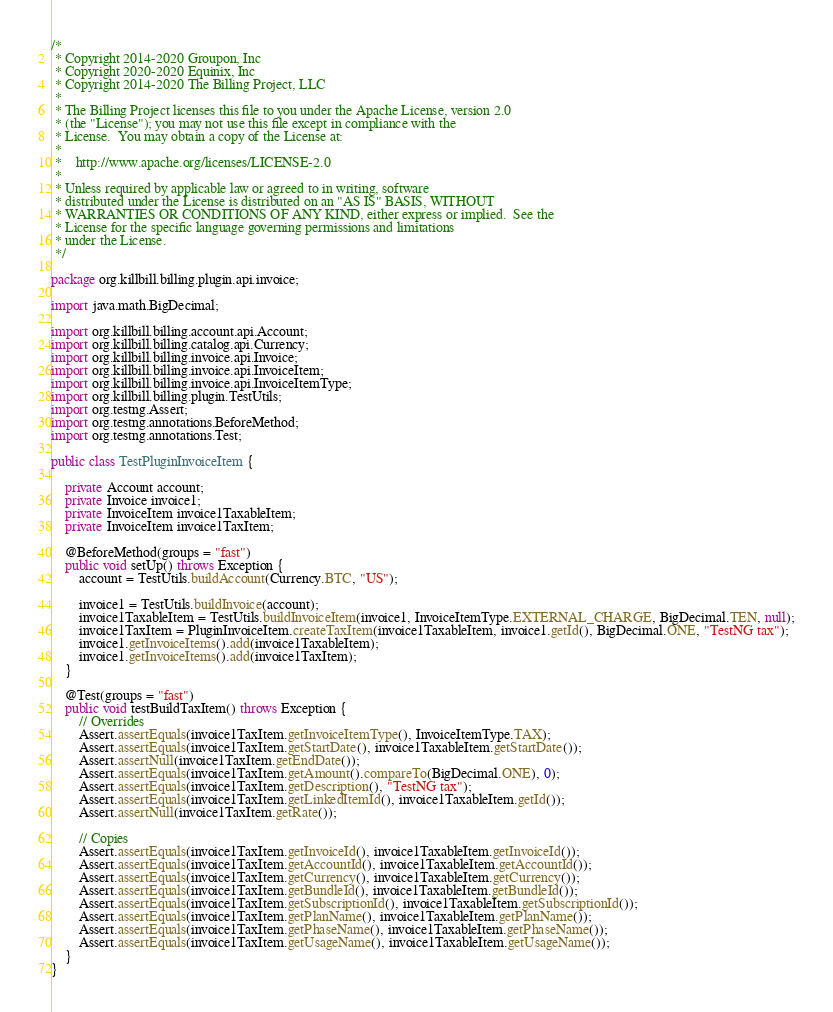<code> <loc_0><loc_0><loc_500><loc_500><_Java_>/*
 * Copyright 2014-2020 Groupon, Inc
 * Copyright 2020-2020 Equinix, Inc
 * Copyright 2014-2020 The Billing Project, LLC
 *
 * The Billing Project licenses this file to you under the Apache License, version 2.0
 * (the "License"); you may not use this file except in compliance with the
 * License.  You may obtain a copy of the License at:
 *
 *    http://www.apache.org/licenses/LICENSE-2.0
 *
 * Unless required by applicable law or agreed to in writing, software
 * distributed under the License is distributed on an "AS IS" BASIS, WITHOUT
 * WARRANTIES OR CONDITIONS OF ANY KIND, either express or implied.  See the
 * License for the specific language governing permissions and limitations
 * under the License.
 */

package org.killbill.billing.plugin.api.invoice;

import java.math.BigDecimal;

import org.killbill.billing.account.api.Account;
import org.killbill.billing.catalog.api.Currency;
import org.killbill.billing.invoice.api.Invoice;
import org.killbill.billing.invoice.api.InvoiceItem;
import org.killbill.billing.invoice.api.InvoiceItemType;
import org.killbill.billing.plugin.TestUtils;
import org.testng.Assert;
import org.testng.annotations.BeforeMethod;
import org.testng.annotations.Test;

public class TestPluginInvoiceItem {

    private Account account;
    private Invoice invoice1;
    private InvoiceItem invoice1TaxableItem;
    private InvoiceItem invoice1TaxItem;

    @BeforeMethod(groups = "fast")
    public void setUp() throws Exception {
        account = TestUtils.buildAccount(Currency.BTC, "US");

        invoice1 = TestUtils.buildInvoice(account);
        invoice1TaxableItem = TestUtils.buildInvoiceItem(invoice1, InvoiceItemType.EXTERNAL_CHARGE, BigDecimal.TEN, null);
        invoice1TaxItem = PluginInvoiceItem.createTaxItem(invoice1TaxableItem, invoice1.getId(), BigDecimal.ONE, "TestNG tax");
        invoice1.getInvoiceItems().add(invoice1TaxableItem);
        invoice1.getInvoiceItems().add(invoice1TaxItem);
    }

    @Test(groups = "fast")
    public void testBuildTaxItem() throws Exception {
        // Overrides
        Assert.assertEquals(invoice1TaxItem.getInvoiceItemType(), InvoiceItemType.TAX);
        Assert.assertEquals(invoice1TaxItem.getStartDate(), invoice1TaxableItem.getStartDate());
        Assert.assertNull(invoice1TaxItem.getEndDate());
        Assert.assertEquals(invoice1TaxItem.getAmount().compareTo(BigDecimal.ONE), 0);
        Assert.assertEquals(invoice1TaxItem.getDescription(), "TestNG tax");
        Assert.assertEquals(invoice1TaxItem.getLinkedItemId(), invoice1TaxableItem.getId());
        Assert.assertNull(invoice1TaxItem.getRate());

        // Copies
        Assert.assertEquals(invoice1TaxItem.getInvoiceId(), invoice1TaxableItem.getInvoiceId());
        Assert.assertEquals(invoice1TaxItem.getAccountId(), invoice1TaxableItem.getAccountId());
        Assert.assertEquals(invoice1TaxItem.getCurrency(), invoice1TaxableItem.getCurrency());
        Assert.assertEquals(invoice1TaxItem.getBundleId(), invoice1TaxableItem.getBundleId());
        Assert.assertEquals(invoice1TaxItem.getSubscriptionId(), invoice1TaxableItem.getSubscriptionId());
        Assert.assertEquals(invoice1TaxItem.getPlanName(), invoice1TaxableItem.getPlanName());
        Assert.assertEquals(invoice1TaxItem.getPhaseName(), invoice1TaxableItem.getPhaseName());
        Assert.assertEquals(invoice1TaxItem.getUsageName(), invoice1TaxableItem.getUsageName());
    }
}
</code> 